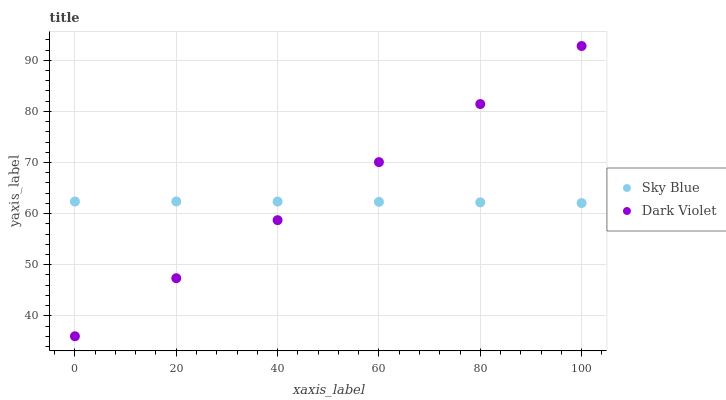Does Sky Blue have the minimum area under the curve?
Answer yes or no. Yes. Does Dark Violet have the maximum area under the curve?
Answer yes or no. Yes. Does Dark Violet have the minimum area under the curve?
Answer yes or no. No. Is Dark Violet the smoothest?
Answer yes or no. Yes. Is Sky Blue the roughest?
Answer yes or no. Yes. Is Dark Violet the roughest?
Answer yes or no. No. Does Dark Violet have the lowest value?
Answer yes or no. Yes. Does Dark Violet have the highest value?
Answer yes or no. Yes. Does Sky Blue intersect Dark Violet?
Answer yes or no. Yes. Is Sky Blue less than Dark Violet?
Answer yes or no. No. Is Sky Blue greater than Dark Violet?
Answer yes or no. No. 